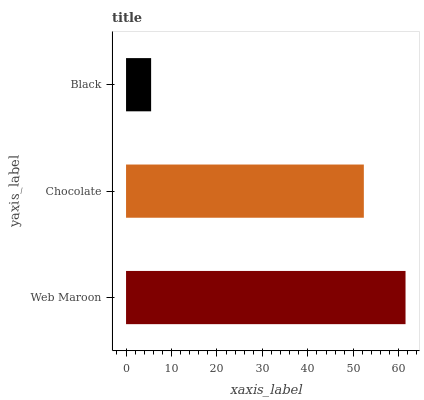Is Black the minimum?
Answer yes or no. Yes. Is Web Maroon the maximum?
Answer yes or no. Yes. Is Chocolate the minimum?
Answer yes or no. No. Is Chocolate the maximum?
Answer yes or no. No. Is Web Maroon greater than Chocolate?
Answer yes or no. Yes. Is Chocolate less than Web Maroon?
Answer yes or no. Yes. Is Chocolate greater than Web Maroon?
Answer yes or no. No. Is Web Maroon less than Chocolate?
Answer yes or no. No. Is Chocolate the high median?
Answer yes or no. Yes. Is Chocolate the low median?
Answer yes or no. Yes. Is Web Maroon the high median?
Answer yes or no. No. Is Black the low median?
Answer yes or no. No. 